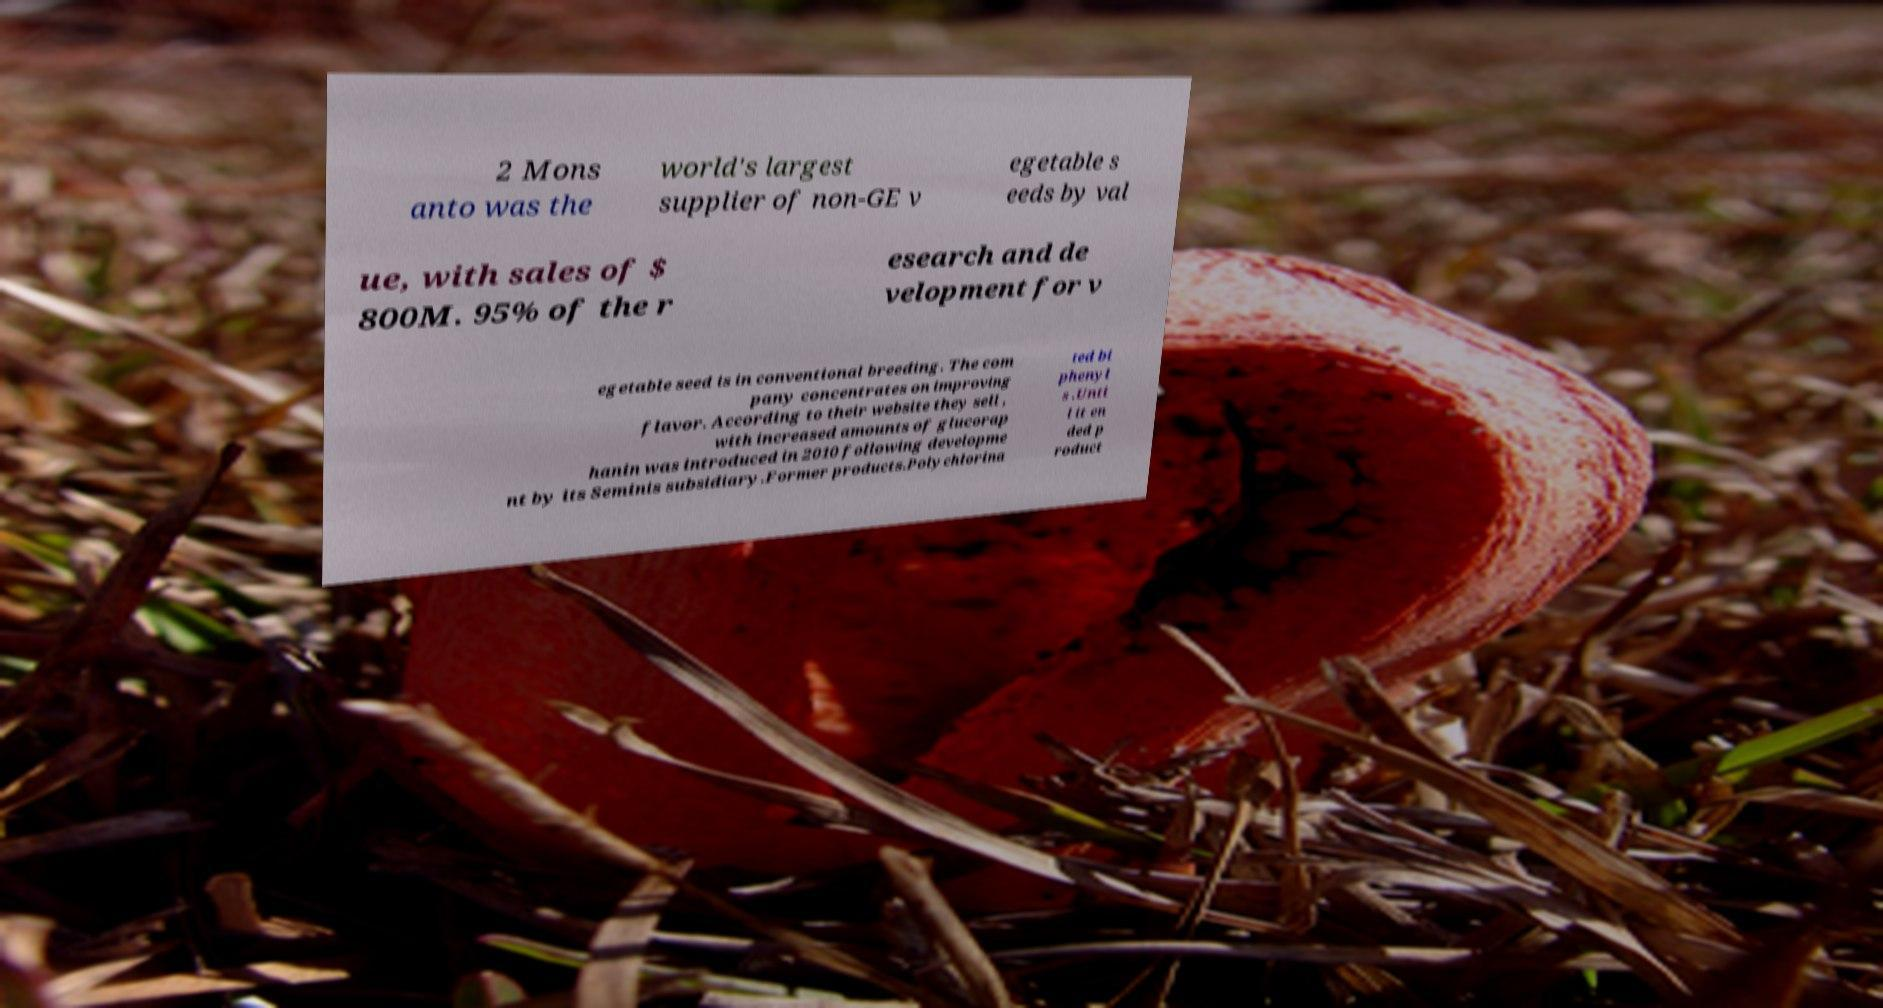For documentation purposes, I need the text within this image transcribed. Could you provide that? 2 Mons anto was the world's largest supplier of non-GE v egetable s eeds by val ue, with sales of $ 800M. 95% of the r esearch and de velopment for v egetable seed is in conventional breeding. The com pany concentrates on improving flavor. According to their website they sell , with increased amounts of glucorap hanin was introduced in 2010 following developme nt by its Seminis subsidiary.Former products.Polychlorina ted bi phenyl s .Unti l it en ded p roduct 